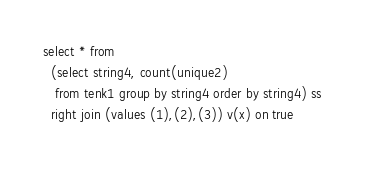Convert code to text. <code><loc_0><loc_0><loc_500><loc_500><_SQL_>select * from
  (select string4, count(unique2)
   from tenk1 group by string4 order by string4) ss
  right join (values (1),(2),(3)) v(x) on true
</code> 